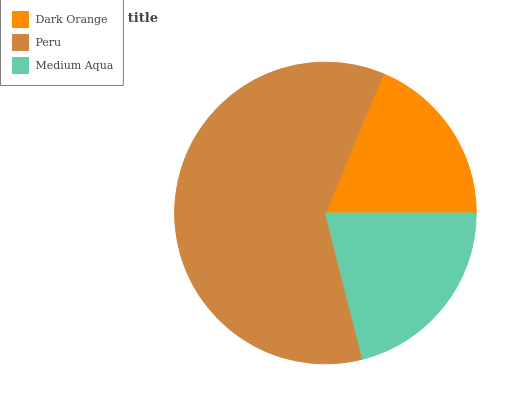Is Dark Orange the minimum?
Answer yes or no. Yes. Is Peru the maximum?
Answer yes or no. Yes. Is Medium Aqua the minimum?
Answer yes or no. No. Is Medium Aqua the maximum?
Answer yes or no. No. Is Peru greater than Medium Aqua?
Answer yes or no. Yes. Is Medium Aqua less than Peru?
Answer yes or no. Yes. Is Medium Aqua greater than Peru?
Answer yes or no. No. Is Peru less than Medium Aqua?
Answer yes or no. No. Is Medium Aqua the high median?
Answer yes or no. Yes. Is Medium Aqua the low median?
Answer yes or no. Yes. Is Peru the high median?
Answer yes or no. No. Is Dark Orange the low median?
Answer yes or no. No. 